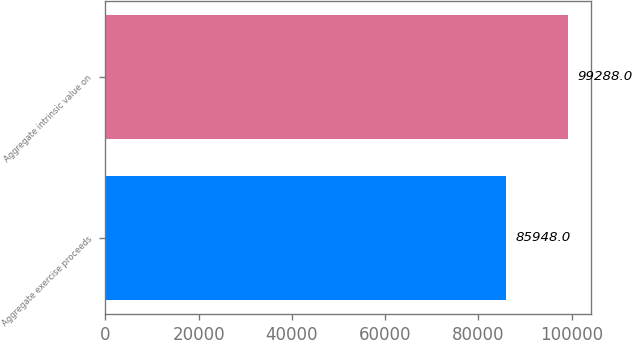Convert chart to OTSL. <chart><loc_0><loc_0><loc_500><loc_500><bar_chart><fcel>Aggregate exercise proceeds<fcel>Aggregate intrinsic value on<nl><fcel>85948<fcel>99288<nl></chart> 